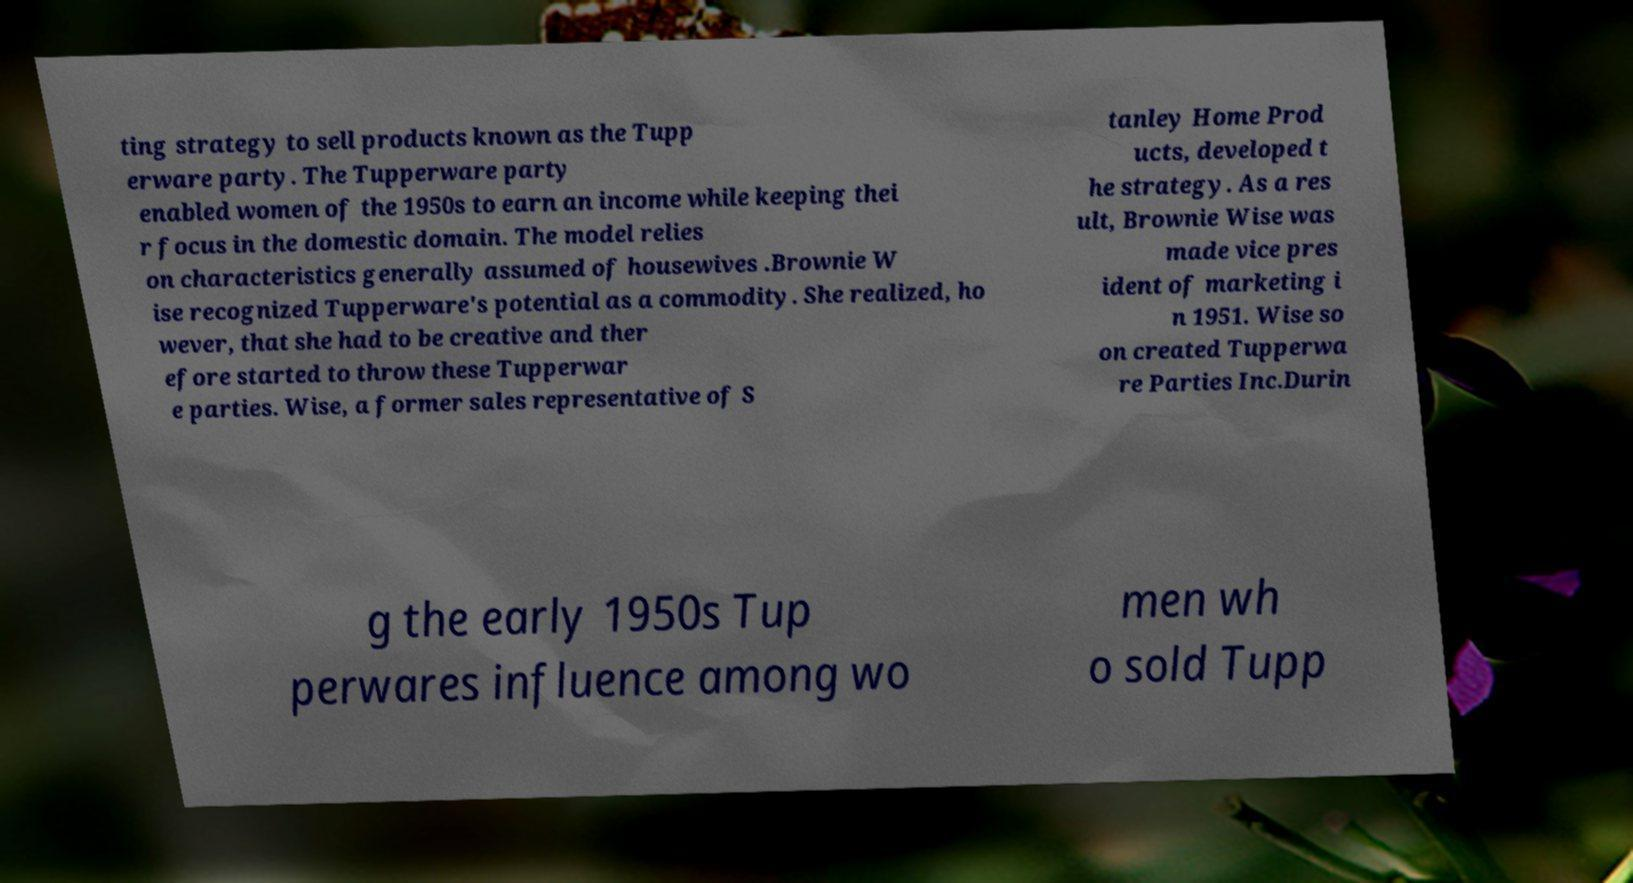Can you read and provide the text displayed in the image?This photo seems to have some interesting text. Can you extract and type it out for me? ting strategy to sell products known as the Tupp erware party. The Tupperware party enabled women of the 1950s to earn an income while keeping thei r focus in the domestic domain. The model relies on characteristics generally assumed of housewives .Brownie W ise recognized Tupperware's potential as a commodity. She realized, ho wever, that she had to be creative and ther efore started to throw these Tupperwar e parties. Wise, a former sales representative of S tanley Home Prod ucts, developed t he strategy. As a res ult, Brownie Wise was made vice pres ident of marketing i n 1951. Wise so on created Tupperwa re Parties Inc.Durin g the early 1950s Tup perwares influence among wo men wh o sold Tupp 